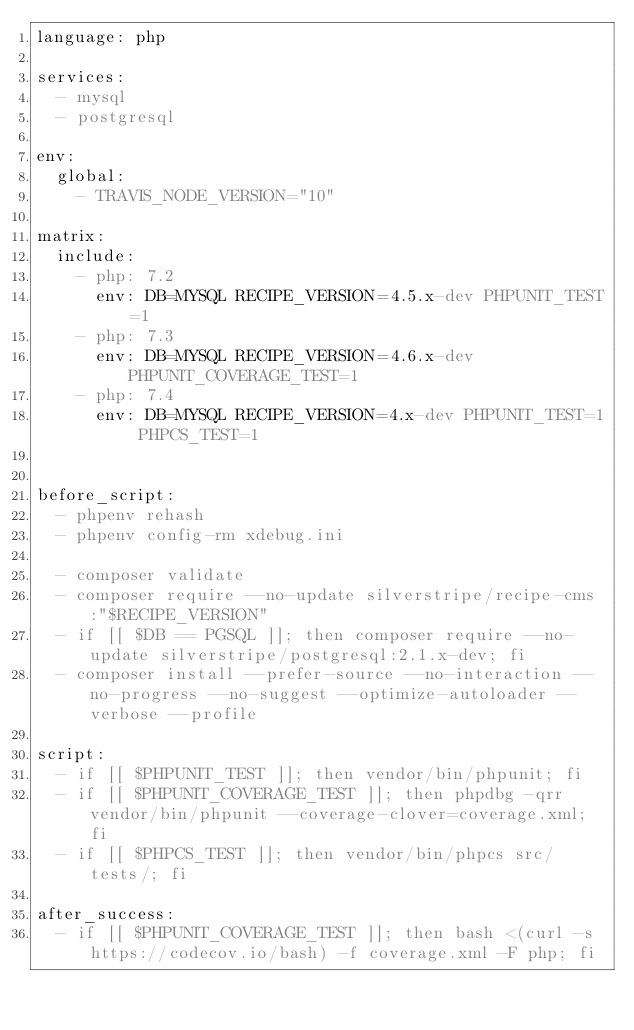Convert code to text. <code><loc_0><loc_0><loc_500><loc_500><_YAML_>language: php

services:
  - mysql
  - postgresql

env:
  global:
    - TRAVIS_NODE_VERSION="10"

matrix:
  include:
    - php: 7.2
      env: DB=MYSQL RECIPE_VERSION=4.5.x-dev PHPUNIT_TEST=1
    - php: 7.3
      env: DB=MYSQL RECIPE_VERSION=4.6.x-dev PHPUNIT_COVERAGE_TEST=1
    - php: 7.4
      env: DB=MYSQL RECIPE_VERSION=4.x-dev PHPUNIT_TEST=1 PHPCS_TEST=1


before_script:
  - phpenv rehash
  - phpenv config-rm xdebug.ini

  - composer validate
  - composer require --no-update silverstripe/recipe-cms:"$RECIPE_VERSION"
  - if [[ $DB == PGSQL ]]; then composer require --no-update silverstripe/postgresql:2.1.x-dev; fi
  - composer install --prefer-source --no-interaction --no-progress --no-suggest --optimize-autoloader --verbose --profile

script:
  - if [[ $PHPUNIT_TEST ]]; then vendor/bin/phpunit; fi
  - if [[ $PHPUNIT_COVERAGE_TEST ]]; then phpdbg -qrr vendor/bin/phpunit --coverage-clover=coverage.xml; fi
  - if [[ $PHPCS_TEST ]]; then vendor/bin/phpcs src/ tests/; fi

after_success:
  - if [[ $PHPUNIT_COVERAGE_TEST ]]; then bash <(curl -s https://codecov.io/bash) -f coverage.xml -F php; fi
</code> 